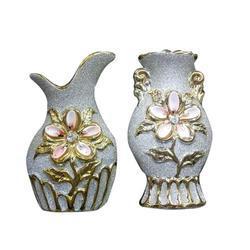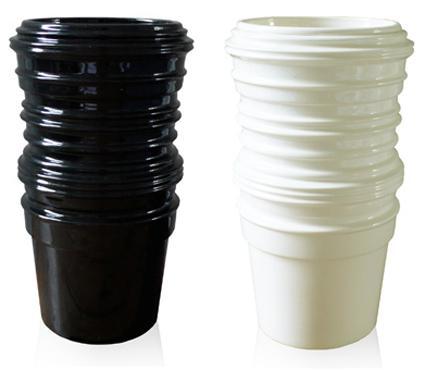The first image is the image on the left, the second image is the image on the right. Examine the images to the left and right. Is the description "There are 4 vases standing upright." accurate? Answer yes or no. Yes. The first image is the image on the left, the second image is the image on the right. Evaluate the accuracy of this statement regarding the images: "At least one of the vases contains a plant with leaves.". Is it true? Answer yes or no. No. 